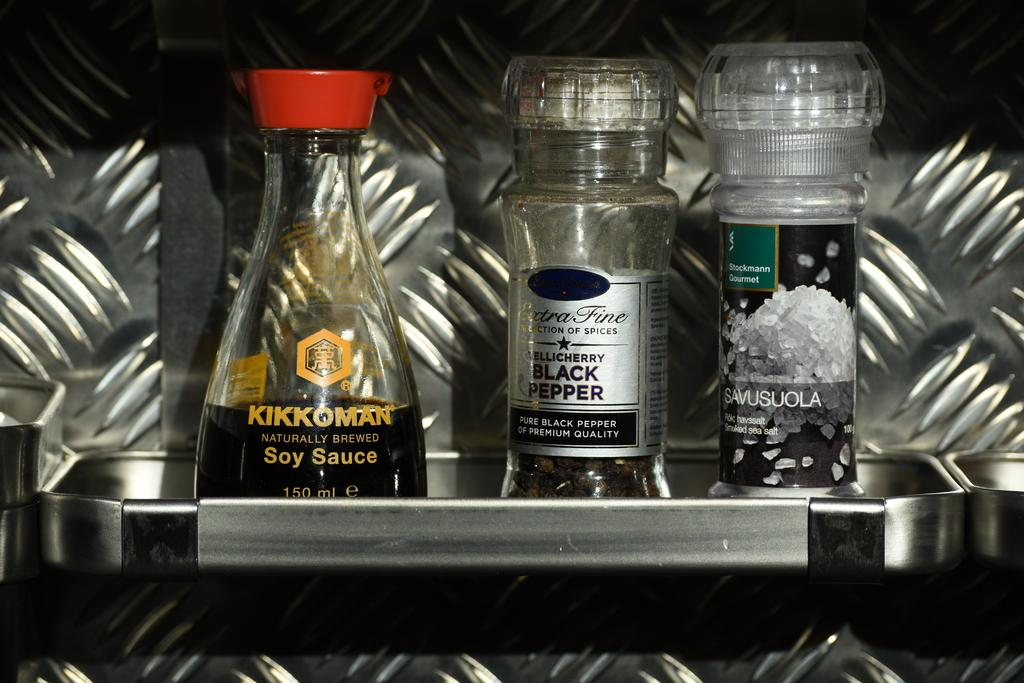<image>
Create a compact narrative representing the image presented. Kikkoman soy sauce and some pepper sit on a tray. 